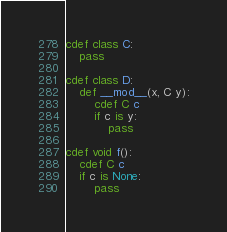Convert code to text. <code><loc_0><loc_0><loc_500><loc_500><_Cython_>cdef class C:
	pass

cdef class D:
	def __mod__(x, C y):
		cdef C c
		if c is y:
			pass

cdef void f():
	cdef C c
	if c is None:
		pass
</code> 